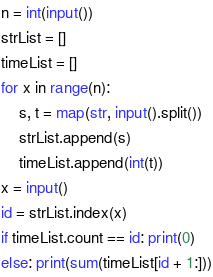Convert code to text. <code><loc_0><loc_0><loc_500><loc_500><_Python_>n = int(input())
strList = []
timeList = []
for x in range(n):
    s, t = map(str, input().split())
    strList.append(s)
    timeList.append(int(t))
x = input()
id = strList.index(x)
if timeList.count == id: print(0)
else: print(sum(timeList[id + 1:]))</code> 